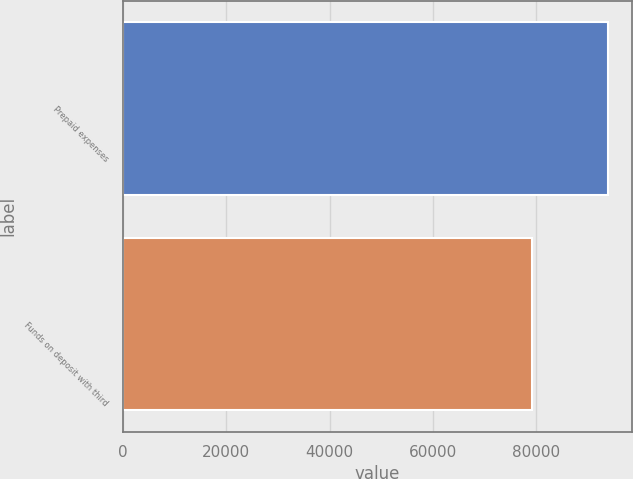<chart> <loc_0><loc_0><loc_500><loc_500><bar_chart><fcel>Prepaid expenses<fcel>Funds on deposit with third<nl><fcel>93877<fcel>79317<nl></chart> 